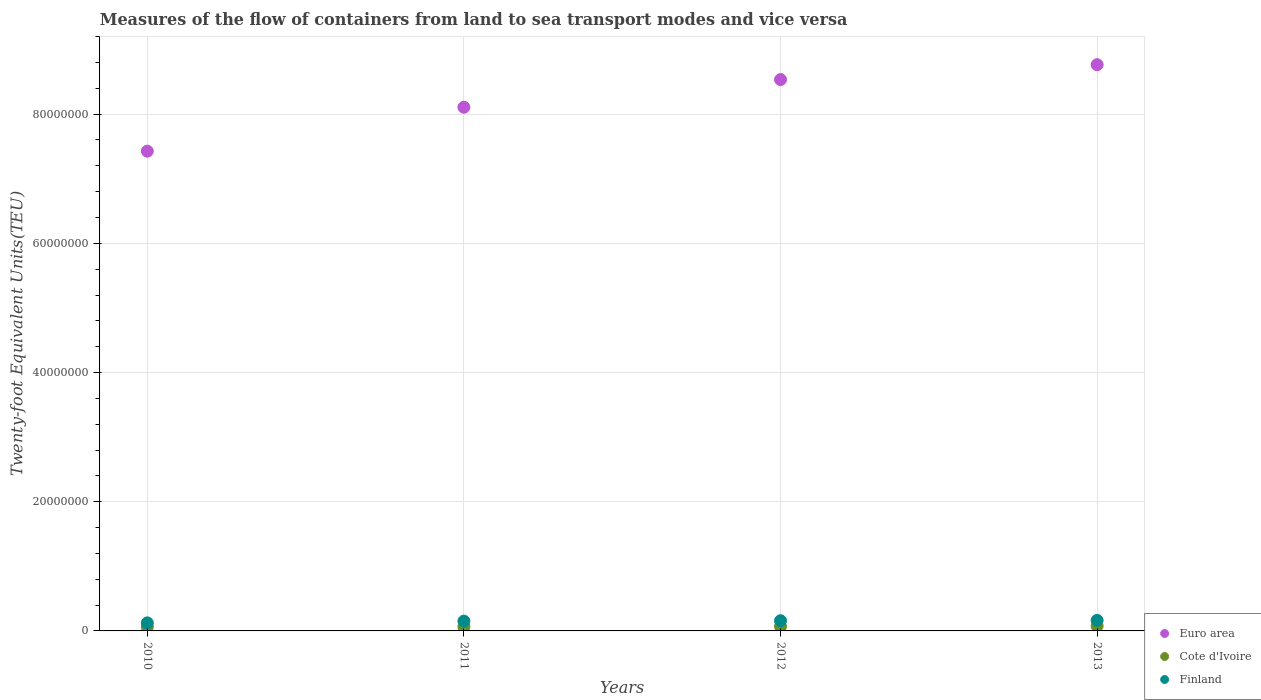How many different coloured dotlines are there?
Provide a succinct answer. 3. Is the number of dotlines equal to the number of legend labels?
Your answer should be compact. Yes. What is the container port traffic in Euro area in 2010?
Offer a very short reply. 7.43e+07. Across all years, what is the maximum container port traffic in Euro area?
Your answer should be compact. 8.77e+07. Across all years, what is the minimum container port traffic in Finland?
Make the answer very short. 1.25e+06. What is the total container port traffic in Finland in the graph?
Offer a terse response. 5.98e+06. What is the difference between the container port traffic in Cote d'Ivoire in 2011 and that in 2013?
Offer a very short reply. -1.03e+05. What is the difference between the container port traffic in Finland in 2013 and the container port traffic in Cote d'Ivoire in 2012?
Your answer should be very brief. 9.43e+05. What is the average container port traffic in Euro area per year?
Your answer should be compact. 8.21e+07. In the year 2010, what is the difference between the container port traffic in Finland and container port traffic in Cote d'Ivoire?
Your response must be concise. 6.40e+05. What is the ratio of the container port traffic in Cote d'Ivoire in 2011 to that in 2013?
Provide a succinct answer. 0.86. Is the container port traffic in Cote d'Ivoire in 2010 less than that in 2011?
Make the answer very short. Yes. What is the difference between the highest and the second highest container port traffic in Finland?
Offer a very short reply. 5.09e+04. What is the difference between the highest and the lowest container port traffic in Finland?
Keep it short and to the point. 3.86e+05. In how many years, is the container port traffic in Euro area greater than the average container port traffic in Euro area taken over all years?
Give a very brief answer. 2. Is the container port traffic in Euro area strictly less than the container port traffic in Cote d'Ivoire over the years?
Provide a short and direct response. No. Are the values on the major ticks of Y-axis written in scientific E-notation?
Offer a terse response. No. Does the graph contain any zero values?
Make the answer very short. No. How are the legend labels stacked?
Give a very brief answer. Vertical. What is the title of the graph?
Offer a terse response. Measures of the flow of containers from land to sea transport modes and vice versa. Does "West Bank and Gaza" appear as one of the legend labels in the graph?
Ensure brevity in your answer.  No. What is the label or title of the X-axis?
Your answer should be very brief. Years. What is the label or title of the Y-axis?
Offer a very short reply. Twenty-foot Equivalent Units(TEU). What is the Twenty-foot Equivalent Units(TEU) in Euro area in 2010?
Make the answer very short. 7.43e+07. What is the Twenty-foot Equivalent Units(TEU) in Cote d'Ivoire in 2010?
Provide a short and direct response. 6.08e+05. What is the Twenty-foot Equivalent Units(TEU) of Finland in 2010?
Offer a very short reply. 1.25e+06. What is the Twenty-foot Equivalent Units(TEU) of Euro area in 2011?
Keep it short and to the point. 8.11e+07. What is the Twenty-foot Equivalent Units(TEU) in Cote d'Ivoire in 2011?
Your answer should be very brief. 6.42e+05. What is the Twenty-foot Equivalent Units(TEU) of Finland in 2011?
Ensure brevity in your answer.  1.52e+06. What is the Twenty-foot Equivalent Units(TEU) in Euro area in 2012?
Make the answer very short. 8.53e+07. What is the Twenty-foot Equivalent Units(TEU) in Cote d'Ivoire in 2012?
Make the answer very short. 6.91e+05. What is the Twenty-foot Equivalent Units(TEU) of Finland in 2012?
Make the answer very short. 1.58e+06. What is the Twenty-foot Equivalent Units(TEU) of Euro area in 2013?
Ensure brevity in your answer.  8.77e+07. What is the Twenty-foot Equivalent Units(TEU) of Cote d'Ivoire in 2013?
Your response must be concise. 7.45e+05. What is the Twenty-foot Equivalent Units(TEU) in Finland in 2013?
Your answer should be compact. 1.63e+06. Across all years, what is the maximum Twenty-foot Equivalent Units(TEU) of Euro area?
Your answer should be very brief. 8.77e+07. Across all years, what is the maximum Twenty-foot Equivalent Units(TEU) of Cote d'Ivoire?
Provide a short and direct response. 7.45e+05. Across all years, what is the maximum Twenty-foot Equivalent Units(TEU) in Finland?
Your answer should be very brief. 1.63e+06. Across all years, what is the minimum Twenty-foot Equivalent Units(TEU) in Euro area?
Make the answer very short. 7.43e+07. Across all years, what is the minimum Twenty-foot Equivalent Units(TEU) of Cote d'Ivoire?
Offer a very short reply. 6.08e+05. Across all years, what is the minimum Twenty-foot Equivalent Units(TEU) of Finland?
Your answer should be very brief. 1.25e+06. What is the total Twenty-foot Equivalent Units(TEU) in Euro area in the graph?
Offer a terse response. 3.28e+08. What is the total Twenty-foot Equivalent Units(TEU) in Cote d'Ivoire in the graph?
Ensure brevity in your answer.  2.69e+06. What is the total Twenty-foot Equivalent Units(TEU) in Finland in the graph?
Ensure brevity in your answer.  5.98e+06. What is the difference between the Twenty-foot Equivalent Units(TEU) of Euro area in 2010 and that in 2011?
Ensure brevity in your answer.  -6.80e+06. What is the difference between the Twenty-foot Equivalent Units(TEU) in Cote d'Ivoire in 2010 and that in 2011?
Offer a very short reply. -3.46e+04. What is the difference between the Twenty-foot Equivalent Units(TEU) of Finland in 2010 and that in 2011?
Your answer should be compact. -2.72e+05. What is the difference between the Twenty-foot Equivalent Units(TEU) of Euro area in 2010 and that in 2012?
Keep it short and to the point. -1.11e+07. What is the difference between the Twenty-foot Equivalent Units(TEU) in Cote d'Ivoire in 2010 and that in 2012?
Offer a terse response. -8.28e+04. What is the difference between the Twenty-foot Equivalent Units(TEU) of Finland in 2010 and that in 2012?
Offer a very short reply. -3.35e+05. What is the difference between the Twenty-foot Equivalent Units(TEU) in Euro area in 2010 and that in 2013?
Make the answer very short. -1.34e+07. What is the difference between the Twenty-foot Equivalent Units(TEU) in Cote d'Ivoire in 2010 and that in 2013?
Offer a terse response. -1.37e+05. What is the difference between the Twenty-foot Equivalent Units(TEU) in Finland in 2010 and that in 2013?
Ensure brevity in your answer.  -3.86e+05. What is the difference between the Twenty-foot Equivalent Units(TEU) in Euro area in 2011 and that in 2012?
Provide a short and direct response. -4.28e+06. What is the difference between the Twenty-foot Equivalent Units(TEU) of Cote d'Ivoire in 2011 and that in 2012?
Provide a succinct answer. -4.82e+04. What is the difference between the Twenty-foot Equivalent Units(TEU) of Finland in 2011 and that in 2012?
Provide a succinct answer. -6.31e+04. What is the difference between the Twenty-foot Equivalent Units(TEU) of Euro area in 2011 and that in 2013?
Offer a very short reply. -6.59e+06. What is the difference between the Twenty-foot Equivalent Units(TEU) in Cote d'Ivoire in 2011 and that in 2013?
Give a very brief answer. -1.03e+05. What is the difference between the Twenty-foot Equivalent Units(TEU) of Finland in 2011 and that in 2013?
Offer a very short reply. -1.14e+05. What is the difference between the Twenty-foot Equivalent Units(TEU) of Euro area in 2012 and that in 2013?
Your answer should be very brief. -2.31e+06. What is the difference between the Twenty-foot Equivalent Units(TEU) of Cote d'Ivoire in 2012 and that in 2013?
Your answer should be very brief. -5.46e+04. What is the difference between the Twenty-foot Equivalent Units(TEU) of Finland in 2012 and that in 2013?
Give a very brief answer. -5.09e+04. What is the difference between the Twenty-foot Equivalent Units(TEU) of Euro area in 2010 and the Twenty-foot Equivalent Units(TEU) of Cote d'Ivoire in 2011?
Your answer should be compact. 7.36e+07. What is the difference between the Twenty-foot Equivalent Units(TEU) in Euro area in 2010 and the Twenty-foot Equivalent Units(TEU) in Finland in 2011?
Your answer should be compact. 7.27e+07. What is the difference between the Twenty-foot Equivalent Units(TEU) in Cote d'Ivoire in 2010 and the Twenty-foot Equivalent Units(TEU) in Finland in 2011?
Keep it short and to the point. -9.11e+05. What is the difference between the Twenty-foot Equivalent Units(TEU) of Euro area in 2010 and the Twenty-foot Equivalent Units(TEU) of Cote d'Ivoire in 2012?
Provide a short and direct response. 7.36e+07. What is the difference between the Twenty-foot Equivalent Units(TEU) in Euro area in 2010 and the Twenty-foot Equivalent Units(TEU) in Finland in 2012?
Provide a short and direct response. 7.27e+07. What is the difference between the Twenty-foot Equivalent Units(TEU) of Cote d'Ivoire in 2010 and the Twenty-foot Equivalent Units(TEU) of Finland in 2012?
Ensure brevity in your answer.  -9.74e+05. What is the difference between the Twenty-foot Equivalent Units(TEU) in Euro area in 2010 and the Twenty-foot Equivalent Units(TEU) in Cote d'Ivoire in 2013?
Provide a short and direct response. 7.35e+07. What is the difference between the Twenty-foot Equivalent Units(TEU) of Euro area in 2010 and the Twenty-foot Equivalent Units(TEU) of Finland in 2013?
Provide a short and direct response. 7.26e+07. What is the difference between the Twenty-foot Equivalent Units(TEU) of Cote d'Ivoire in 2010 and the Twenty-foot Equivalent Units(TEU) of Finland in 2013?
Make the answer very short. -1.03e+06. What is the difference between the Twenty-foot Equivalent Units(TEU) in Euro area in 2011 and the Twenty-foot Equivalent Units(TEU) in Cote d'Ivoire in 2012?
Keep it short and to the point. 8.04e+07. What is the difference between the Twenty-foot Equivalent Units(TEU) in Euro area in 2011 and the Twenty-foot Equivalent Units(TEU) in Finland in 2012?
Offer a very short reply. 7.95e+07. What is the difference between the Twenty-foot Equivalent Units(TEU) in Cote d'Ivoire in 2011 and the Twenty-foot Equivalent Units(TEU) in Finland in 2012?
Make the answer very short. -9.40e+05. What is the difference between the Twenty-foot Equivalent Units(TEU) of Euro area in 2011 and the Twenty-foot Equivalent Units(TEU) of Cote d'Ivoire in 2013?
Give a very brief answer. 8.03e+07. What is the difference between the Twenty-foot Equivalent Units(TEU) in Euro area in 2011 and the Twenty-foot Equivalent Units(TEU) in Finland in 2013?
Make the answer very short. 7.94e+07. What is the difference between the Twenty-foot Equivalent Units(TEU) in Cote d'Ivoire in 2011 and the Twenty-foot Equivalent Units(TEU) in Finland in 2013?
Make the answer very short. -9.91e+05. What is the difference between the Twenty-foot Equivalent Units(TEU) of Euro area in 2012 and the Twenty-foot Equivalent Units(TEU) of Cote d'Ivoire in 2013?
Offer a very short reply. 8.46e+07. What is the difference between the Twenty-foot Equivalent Units(TEU) in Euro area in 2012 and the Twenty-foot Equivalent Units(TEU) in Finland in 2013?
Offer a very short reply. 8.37e+07. What is the difference between the Twenty-foot Equivalent Units(TEU) in Cote d'Ivoire in 2012 and the Twenty-foot Equivalent Units(TEU) in Finland in 2013?
Ensure brevity in your answer.  -9.43e+05. What is the average Twenty-foot Equivalent Units(TEU) of Euro area per year?
Your response must be concise. 8.21e+07. What is the average Twenty-foot Equivalent Units(TEU) of Cote d'Ivoire per year?
Give a very brief answer. 6.71e+05. What is the average Twenty-foot Equivalent Units(TEU) in Finland per year?
Keep it short and to the point. 1.50e+06. In the year 2010, what is the difference between the Twenty-foot Equivalent Units(TEU) of Euro area and Twenty-foot Equivalent Units(TEU) of Cote d'Ivoire?
Offer a terse response. 7.37e+07. In the year 2010, what is the difference between the Twenty-foot Equivalent Units(TEU) of Euro area and Twenty-foot Equivalent Units(TEU) of Finland?
Make the answer very short. 7.30e+07. In the year 2010, what is the difference between the Twenty-foot Equivalent Units(TEU) in Cote d'Ivoire and Twenty-foot Equivalent Units(TEU) in Finland?
Offer a very short reply. -6.40e+05. In the year 2011, what is the difference between the Twenty-foot Equivalent Units(TEU) in Euro area and Twenty-foot Equivalent Units(TEU) in Cote d'Ivoire?
Ensure brevity in your answer.  8.04e+07. In the year 2011, what is the difference between the Twenty-foot Equivalent Units(TEU) of Euro area and Twenty-foot Equivalent Units(TEU) of Finland?
Offer a terse response. 7.95e+07. In the year 2011, what is the difference between the Twenty-foot Equivalent Units(TEU) of Cote d'Ivoire and Twenty-foot Equivalent Units(TEU) of Finland?
Ensure brevity in your answer.  -8.77e+05. In the year 2012, what is the difference between the Twenty-foot Equivalent Units(TEU) in Euro area and Twenty-foot Equivalent Units(TEU) in Cote d'Ivoire?
Your answer should be compact. 8.47e+07. In the year 2012, what is the difference between the Twenty-foot Equivalent Units(TEU) in Euro area and Twenty-foot Equivalent Units(TEU) in Finland?
Offer a terse response. 8.38e+07. In the year 2012, what is the difference between the Twenty-foot Equivalent Units(TEU) of Cote d'Ivoire and Twenty-foot Equivalent Units(TEU) of Finland?
Keep it short and to the point. -8.92e+05. In the year 2013, what is the difference between the Twenty-foot Equivalent Units(TEU) in Euro area and Twenty-foot Equivalent Units(TEU) in Cote d'Ivoire?
Give a very brief answer. 8.69e+07. In the year 2013, what is the difference between the Twenty-foot Equivalent Units(TEU) in Euro area and Twenty-foot Equivalent Units(TEU) in Finland?
Provide a short and direct response. 8.60e+07. In the year 2013, what is the difference between the Twenty-foot Equivalent Units(TEU) in Cote d'Ivoire and Twenty-foot Equivalent Units(TEU) in Finland?
Your response must be concise. -8.88e+05. What is the ratio of the Twenty-foot Equivalent Units(TEU) of Euro area in 2010 to that in 2011?
Keep it short and to the point. 0.92. What is the ratio of the Twenty-foot Equivalent Units(TEU) of Cote d'Ivoire in 2010 to that in 2011?
Provide a short and direct response. 0.95. What is the ratio of the Twenty-foot Equivalent Units(TEU) of Finland in 2010 to that in 2011?
Provide a short and direct response. 0.82. What is the ratio of the Twenty-foot Equivalent Units(TEU) in Euro area in 2010 to that in 2012?
Give a very brief answer. 0.87. What is the ratio of the Twenty-foot Equivalent Units(TEU) of Cote d'Ivoire in 2010 to that in 2012?
Ensure brevity in your answer.  0.88. What is the ratio of the Twenty-foot Equivalent Units(TEU) in Finland in 2010 to that in 2012?
Your answer should be very brief. 0.79. What is the ratio of the Twenty-foot Equivalent Units(TEU) of Euro area in 2010 to that in 2013?
Provide a succinct answer. 0.85. What is the ratio of the Twenty-foot Equivalent Units(TEU) of Cote d'Ivoire in 2010 to that in 2013?
Offer a very short reply. 0.82. What is the ratio of the Twenty-foot Equivalent Units(TEU) in Finland in 2010 to that in 2013?
Make the answer very short. 0.76. What is the ratio of the Twenty-foot Equivalent Units(TEU) in Euro area in 2011 to that in 2012?
Your answer should be very brief. 0.95. What is the ratio of the Twenty-foot Equivalent Units(TEU) of Cote d'Ivoire in 2011 to that in 2012?
Offer a terse response. 0.93. What is the ratio of the Twenty-foot Equivalent Units(TEU) in Finland in 2011 to that in 2012?
Provide a succinct answer. 0.96. What is the ratio of the Twenty-foot Equivalent Units(TEU) in Euro area in 2011 to that in 2013?
Your answer should be very brief. 0.92. What is the ratio of the Twenty-foot Equivalent Units(TEU) of Cote d'Ivoire in 2011 to that in 2013?
Give a very brief answer. 0.86. What is the ratio of the Twenty-foot Equivalent Units(TEU) in Finland in 2011 to that in 2013?
Keep it short and to the point. 0.93. What is the ratio of the Twenty-foot Equivalent Units(TEU) in Euro area in 2012 to that in 2013?
Ensure brevity in your answer.  0.97. What is the ratio of the Twenty-foot Equivalent Units(TEU) of Cote d'Ivoire in 2012 to that in 2013?
Provide a succinct answer. 0.93. What is the ratio of the Twenty-foot Equivalent Units(TEU) in Finland in 2012 to that in 2013?
Provide a short and direct response. 0.97. What is the difference between the highest and the second highest Twenty-foot Equivalent Units(TEU) in Euro area?
Provide a succinct answer. 2.31e+06. What is the difference between the highest and the second highest Twenty-foot Equivalent Units(TEU) in Cote d'Ivoire?
Provide a short and direct response. 5.46e+04. What is the difference between the highest and the second highest Twenty-foot Equivalent Units(TEU) of Finland?
Keep it short and to the point. 5.09e+04. What is the difference between the highest and the lowest Twenty-foot Equivalent Units(TEU) in Euro area?
Keep it short and to the point. 1.34e+07. What is the difference between the highest and the lowest Twenty-foot Equivalent Units(TEU) of Cote d'Ivoire?
Ensure brevity in your answer.  1.37e+05. What is the difference between the highest and the lowest Twenty-foot Equivalent Units(TEU) in Finland?
Give a very brief answer. 3.86e+05. 